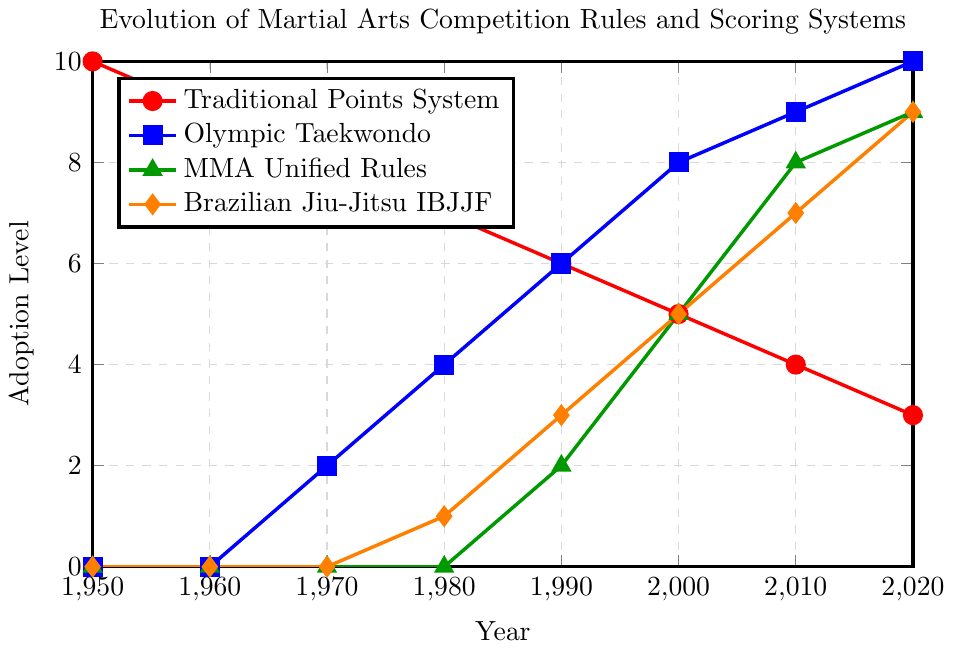What year did Olympic Taekwondo adoption level reach 6? The blue line indicates the adoption level of Olympic Taekwondo. Observing this, we see it reaches an adoption level of 6 in the year 1990.
Answer: 1990 Between 1980 and 2020, which scoring system experienced the biggest increase in adoption level? The MMA Unified Rules (green line) went from an adoption level of 0 in 1980 to 9 in 2020, an increase of 9. This is the largest increase compared to the other systems within the specified period.
Answer: MMA Unified Rules Compare the adoption levels of Traditional Points System and Brazilian Jiu-Jitsu IBJJF in the year 2000. Which one had a higher value? In 2000, the Traditional Points System (red) had an adoption level of 5, while Brazilian Jiu-Jitsu IBJJF (orange) also had an adoption level of 5. Therefore, both had the same value.
Answer: Equal What is the overall trend for the Traditional Points System from 1950 to 2020? The red line shows a clear declining trend in the adoption level of the Traditional Points System, starting from 10 in 1950 and decreasing to 3 in 2020.
Answer: Decreasing What is the difference in adoption levels between MMA Unified Rules and Olympic Taekwondo in 2010? In 2010, the MMA Unified Rules (green) had an adoption level of 8, while Olympic Taekwondo (blue) had an adoption level of 9. The difference is 9 - 8.
Answer: 1 What two scoring systems first appeared on the chart in 1970 and what were their adoption levels? In 1970, Olympic Taekwondo (blue) and Traditional Points System (red) are present. The adoption level for Olympic Taekwondo is 2, and for Traditional Points System is 8.
Answer: Olympic Taekwondo: 2, Traditional Points System: 8 Which scoring system was adopted first, Brazilian Jiu-Jitsu IBJJF or MMA Unified Rules? Brazilian Jiu-Jitsu IBJJF (orange) first appears in 1980 with an adoption level of 1, while MMA Unified Rules (green) appears in 1990 with an adoption level of 2. Therefore, Brazilian Jiu-Jitsu IBJJF was adopted first.
Answer: Brazilian Jiu-Jitsu IBJJF In which decade did the adoption level of Olympic Taekwondo surpass that of the Traditional Points System? Observing the lines, we see that blue (Olympic Taekwondo) surpasses red (Traditional Points System) between 1980 and 1990.
Answer: 1980s What is the average adoption level of MMA Unified Rules across all the years shown? Sum the adoption levels of MMA Unified Rules: 0+0+0+0+2+5+8+9=24, over 8 data points. The average is 24/8.
Answer: 3 How many different scoring systems had an adoption level of 9 in 2020? Looking at the year 2020, MMA Unified Rules (green), Brazilian Jiu-Jitsu IBJJF (orange), and Olympic Taekwondo (blue) each have an adoption level of 9.
Answer: 3 